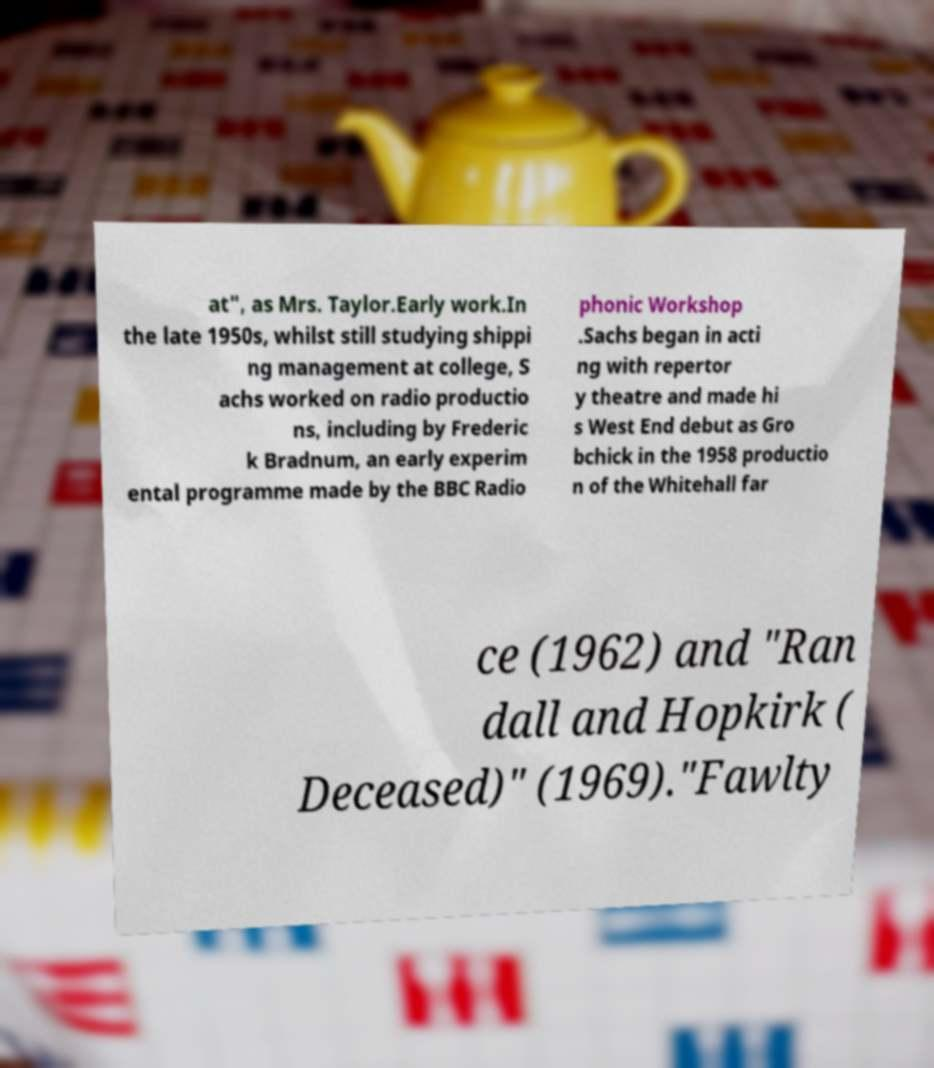Could you assist in decoding the text presented in this image and type it out clearly? at", as Mrs. Taylor.Early work.In the late 1950s, whilst still studying shippi ng management at college, S achs worked on radio productio ns, including by Frederic k Bradnum, an early experim ental programme made by the BBC Radio phonic Workshop .Sachs began in acti ng with repertor y theatre and made hi s West End debut as Gro bchick in the 1958 productio n of the Whitehall far ce (1962) and "Ran dall and Hopkirk ( Deceased)" (1969)."Fawlty 